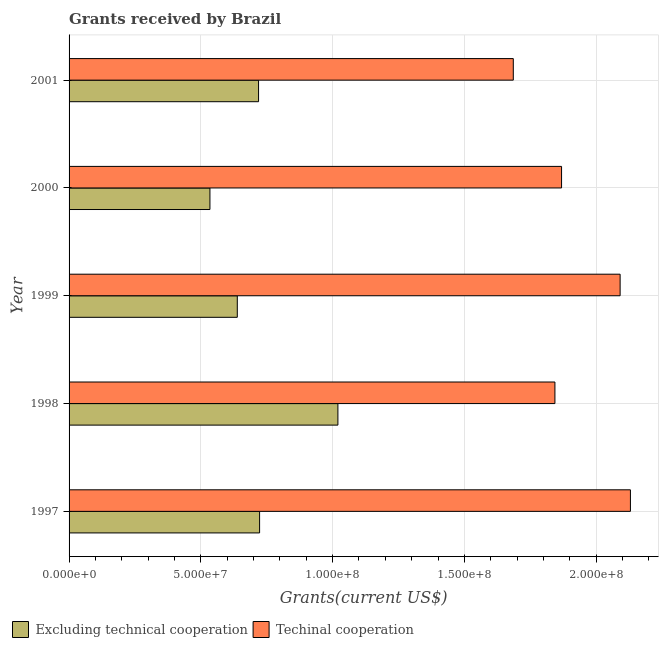How many groups of bars are there?
Your answer should be compact. 5. Are the number of bars per tick equal to the number of legend labels?
Give a very brief answer. Yes. Are the number of bars on each tick of the Y-axis equal?
Your response must be concise. Yes. How many bars are there on the 1st tick from the top?
Your response must be concise. 2. What is the label of the 1st group of bars from the top?
Offer a very short reply. 2001. What is the amount of grants received(including technical cooperation) in 1997?
Your answer should be compact. 2.13e+08. Across all years, what is the maximum amount of grants received(excluding technical cooperation)?
Make the answer very short. 1.02e+08. Across all years, what is the minimum amount of grants received(excluding technical cooperation)?
Offer a terse response. 5.34e+07. In which year was the amount of grants received(including technical cooperation) maximum?
Provide a short and direct response. 1997. What is the total amount of grants received(excluding technical cooperation) in the graph?
Offer a terse response. 3.63e+08. What is the difference between the amount of grants received(including technical cooperation) in 1999 and that in 2001?
Ensure brevity in your answer.  4.05e+07. What is the difference between the amount of grants received(including technical cooperation) in 1998 and the amount of grants received(excluding technical cooperation) in 1999?
Your response must be concise. 1.21e+08. What is the average amount of grants received(excluding technical cooperation) per year?
Make the answer very short. 7.27e+07. In the year 2000, what is the difference between the amount of grants received(including technical cooperation) and amount of grants received(excluding technical cooperation)?
Keep it short and to the point. 1.33e+08. What is the ratio of the amount of grants received(excluding technical cooperation) in 2000 to that in 2001?
Give a very brief answer. 0.74. Is the amount of grants received(including technical cooperation) in 1997 less than that in 1998?
Provide a short and direct response. No. Is the difference between the amount of grants received(including technical cooperation) in 1998 and 1999 greater than the difference between the amount of grants received(excluding technical cooperation) in 1998 and 1999?
Make the answer very short. No. What is the difference between the highest and the second highest amount of grants received(including technical cooperation)?
Your answer should be very brief. 3.91e+06. What is the difference between the highest and the lowest amount of grants received(excluding technical cooperation)?
Provide a succinct answer. 4.86e+07. In how many years, is the amount of grants received(including technical cooperation) greater than the average amount of grants received(including technical cooperation) taken over all years?
Your answer should be compact. 2. What does the 1st bar from the top in 2001 represents?
Offer a terse response. Techinal cooperation. What does the 2nd bar from the bottom in 1998 represents?
Give a very brief answer. Techinal cooperation. How many bars are there?
Offer a very short reply. 10. Are all the bars in the graph horizontal?
Your answer should be compact. Yes. How many years are there in the graph?
Provide a succinct answer. 5. Are the values on the major ticks of X-axis written in scientific E-notation?
Offer a very short reply. Yes. Does the graph contain any zero values?
Keep it short and to the point. No. Does the graph contain grids?
Your answer should be compact. Yes. Where does the legend appear in the graph?
Offer a terse response. Bottom left. How many legend labels are there?
Offer a terse response. 2. How are the legend labels stacked?
Provide a succinct answer. Horizontal. What is the title of the graph?
Offer a very short reply. Grants received by Brazil. Does "Researchers" appear as one of the legend labels in the graph?
Provide a short and direct response. No. What is the label or title of the X-axis?
Your response must be concise. Grants(current US$). What is the label or title of the Y-axis?
Give a very brief answer. Year. What is the Grants(current US$) of Excluding technical cooperation in 1997?
Keep it short and to the point. 7.23e+07. What is the Grants(current US$) in Techinal cooperation in 1997?
Make the answer very short. 2.13e+08. What is the Grants(current US$) of Excluding technical cooperation in 1998?
Offer a terse response. 1.02e+08. What is the Grants(current US$) of Techinal cooperation in 1998?
Give a very brief answer. 1.84e+08. What is the Grants(current US$) of Excluding technical cooperation in 1999?
Offer a terse response. 6.38e+07. What is the Grants(current US$) in Techinal cooperation in 1999?
Keep it short and to the point. 2.09e+08. What is the Grants(current US$) in Excluding technical cooperation in 2000?
Give a very brief answer. 5.34e+07. What is the Grants(current US$) in Techinal cooperation in 2000?
Offer a very short reply. 1.87e+08. What is the Grants(current US$) in Excluding technical cooperation in 2001?
Give a very brief answer. 7.19e+07. What is the Grants(current US$) of Techinal cooperation in 2001?
Your response must be concise. 1.69e+08. Across all years, what is the maximum Grants(current US$) of Excluding technical cooperation?
Your response must be concise. 1.02e+08. Across all years, what is the maximum Grants(current US$) of Techinal cooperation?
Provide a succinct answer. 2.13e+08. Across all years, what is the minimum Grants(current US$) of Excluding technical cooperation?
Ensure brevity in your answer.  5.34e+07. Across all years, what is the minimum Grants(current US$) of Techinal cooperation?
Give a very brief answer. 1.69e+08. What is the total Grants(current US$) in Excluding technical cooperation in the graph?
Keep it short and to the point. 3.63e+08. What is the total Grants(current US$) of Techinal cooperation in the graph?
Provide a succinct answer. 9.62e+08. What is the difference between the Grants(current US$) of Excluding technical cooperation in 1997 and that in 1998?
Make the answer very short. -2.97e+07. What is the difference between the Grants(current US$) in Techinal cooperation in 1997 and that in 1998?
Provide a succinct answer. 2.86e+07. What is the difference between the Grants(current US$) in Excluding technical cooperation in 1997 and that in 1999?
Provide a short and direct response. 8.46e+06. What is the difference between the Grants(current US$) in Techinal cooperation in 1997 and that in 1999?
Provide a succinct answer. 3.91e+06. What is the difference between the Grants(current US$) in Excluding technical cooperation in 1997 and that in 2000?
Provide a succinct answer. 1.88e+07. What is the difference between the Grants(current US$) in Techinal cooperation in 1997 and that in 2000?
Your response must be concise. 2.61e+07. What is the difference between the Grants(current US$) in Excluding technical cooperation in 1997 and that in 2001?
Offer a very short reply. 3.90e+05. What is the difference between the Grants(current US$) of Techinal cooperation in 1997 and that in 2001?
Your response must be concise. 4.44e+07. What is the difference between the Grants(current US$) of Excluding technical cooperation in 1998 and that in 1999?
Give a very brief answer. 3.82e+07. What is the difference between the Grants(current US$) in Techinal cooperation in 1998 and that in 1999?
Make the answer very short. -2.47e+07. What is the difference between the Grants(current US$) of Excluding technical cooperation in 1998 and that in 2000?
Provide a short and direct response. 4.86e+07. What is the difference between the Grants(current US$) of Techinal cooperation in 1998 and that in 2000?
Your response must be concise. -2.52e+06. What is the difference between the Grants(current US$) in Excluding technical cooperation in 1998 and that in 2001?
Give a very brief answer. 3.01e+07. What is the difference between the Grants(current US$) of Techinal cooperation in 1998 and that in 2001?
Your answer should be compact. 1.58e+07. What is the difference between the Grants(current US$) in Excluding technical cooperation in 1999 and that in 2000?
Your answer should be very brief. 1.04e+07. What is the difference between the Grants(current US$) in Techinal cooperation in 1999 and that in 2000?
Offer a very short reply. 2.22e+07. What is the difference between the Grants(current US$) of Excluding technical cooperation in 1999 and that in 2001?
Your answer should be very brief. -8.07e+06. What is the difference between the Grants(current US$) in Techinal cooperation in 1999 and that in 2001?
Provide a short and direct response. 4.05e+07. What is the difference between the Grants(current US$) of Excluding technical cooperation in 2000 and that in 2001?
Ensure brevity in your answer.  -1.84e+07. What is the difference between the Grants(current US$) in Techinal cooperation in 2000 and that in 2001?
Make the answer very short. 1.83e+07. What is the difference between the Grants(current US$) in Excluding technical cooperation in 1997 and the Grants(current US$) in Techinal cooperation in 1998?
Offer a terse response. -1.12e+08. What is the difference between the Grants(current US$) in Excluding technical cooperation in 1997 and the Grants(current US$) in Techinal cooperation in 1999?
Keep it short and to the point. -1.37e+08. What is the difference between the Grants(current US$) in Excluding technical cooperation in 1997 and the Grants(current US$) in Techinal cooperation in 2000?
Offer a terse response. -1.15e+08. What is the difference between the Grants(current US$) of Excluding technical cooperation in 1997 and the Grants(current US$) of Techinal cooperation in 2001?
Ensure brevity in your answer.  -9.63e+07. What is the difference between the Grants(current US$) of Excluding technical cooperation in 1998 and the Grants(current US$) of Techinal cooperation in 1999?
Give a very brief answer. -1.07e+08. What is the difference between the Grants(current US$) of Excluding technical cooperation in 1998 and the Grants(current US$) of Techinal cooperation in 2000?
Your answer should be very brief. -8.49e+07. What is the difference between the Grants(current US$) of Excluding technical cooperation in 1998 and the Grants(current US$) of Techinal cooperation in 2001?
Give a very brief answer. -6.66e+07. What is the difference between the Grants(current US$) of Excluding technical cooperation in 1999 and the Grants(current US$) of Techinal cooperation in 2000?
Provide a short and direct response. -1.23e+08. What is the difference between the Grants(current US$) in Excluding technical cooperation in 1999 and the Grants(current US$) in Techinal cooperation in 2001?
Offer a very short reply. -1.05e+08. What is the difference between the Grants(current US$) of Excluding technical cooperation in 2000 and the Grants(current US$) of Techinal cooperation in 2001?
Keep it short and to the point. -1.15e+08. What is the average Grants(current US$) of Excluding technical cooperation per year?
Offer a terse response. 7.27e+07. What is the average Grants(current US$) in Techinal cooperation per year?
Keep it short and to the point. 1.92e+08. In the year 1997, what is the difference between the Grants(current US$) of Excluding technical cooperation and Grants(current US$) of Techinal cooperation?
Provide a succinct answer. -1.41e+08. In the year 1998, what is the difference between the Grants(current US$) in Excluding technical cooperation and Grants(current US$) in Techinal cooperation?
Your answer should be very brief. -8.23e+07. In the year 1999, what is the difference between the Grants(current US$) in Excluding technical cooperation and Grants(current US$) in Techinal cooperation?
Provide a succinct answer. -1.45e+08. In the year 2000, what is the difference between the Grants(current US$) in Excluding technical cooperation and Grants(current US$) in Techinal cooperation?
Provide a short and direct response. -1.33e+08. In the year 2001, what is the difference between the Grants(current US$) in Excluding technical cooperation and Grants(current US$) in Techinal cooperation?
Your answer should be compact. -9.66e+07. What is the ratio of the Grants(current US$) in Excluding technical cooperation in 1997 to that in 1998?
Provide a succinct answer. 0.71. What is the ratio of the Grants(current US$) of Techinal cooperation in 1997 to that in 1998?
Your response must be concise. 1.16. What is the ratio of the Grants(current US$) of Excluding technical cooperation in 1997 to that in 1999?
Provide a short and direct response. 1.13. What is the ratio of the Grants(current US$) of Techinal cooperation in 1997 to that in 1999?
Give a very brief answer. 1.02. What is the ratio of the Grants(current US$) in Excluding technical cooperation in 1997 to that in 2000?
Offer a very short reply. 1.35. What is the ratio of the Grants(current US$) of Techinal cooperation in 1997 to that in 2000?
Offer a terse response. 1.14. What is the ratio of the Grants(current US$) of Excluding technical cooperation in 1997 to that in 2001?
Give a very brief answer. 1.01. What is the ratio of the Grants(current US$) of Techinal cooperation in 1997 to that in 2001?
Your response must be concise. 1.26. What is the ratio of the Grants(current US$) of Excluding technical cooperation in 1998 to that in 1999?
Make the answer very short. 1.6. What is the ratio of the Grants(current US$) of Techinal cooperation in 1998 to that in 1999?
Offer a terse response. 0.88. What is the ratio of the Grants(current US$) of Excluding technical cooperation in 1998 to that in 2000?
Keep it short and to the point. 1.91. What is the ratio of the Grants(current US$) in Techinal cooperation in 1998 to that in 2000?
Keep it short and to the point. 0.99. What is the ratio of the Grants(current US$) in Excluding technical cooperation in 1998 to that in 2001?
Your answer should be very brief. 1.42. What is the ratio of the Grants(current US$) in Techinal cooperation in 1998 to that in 2001?
Give a very brief answer. 1.09. What is the ratio of the Grants(current US$) in Excluding technical cooperation in 1999 to that in 2000?
Your answer should be compact. 1.19. What is the ratio of the Grants(current US$) of Techinal cooperation in 1999 to that in 2000?
Your answer should be very brief. 1.12. What is the ratio of the Grants(current US$) of Excluding technical cooperation in 1999 to that in 2001?
Your response must be concise. 0.89. What is the ratio of the Grants(current US$) of Techinal cooperation in 1999 to that in 2001?
Offer a terse response. 1.24. What is the ratio of the Grants(current US$) in Excluding technical cooperation in 2000 to that in 2001?
Provide a short and direct response. 0.74. What is the ratio of the Grants(current US$) of Techinal cooperation in 2000 to that in 2001?
Offer a terse response. 1.11. What is the difference between the highest and the second highest Grants(current US$) in Excluding technical cooperation?
Your answer should be very brief. 2.97e+07. What is the difference between the highest and the second highest Grants(current US$) in Techinal cooperation?
Ensure brevity in your answer.  3.91e+06. What is the difference between the highest and the lowest Grants(current US$) of Excluding technical cooperation?
Provide a succinct answer. 4.86e+07. What is the difference between the highest and the lowest Grants(current US$) of Techinal cooperation?
Offer a very short reply. 4.44e+07. 